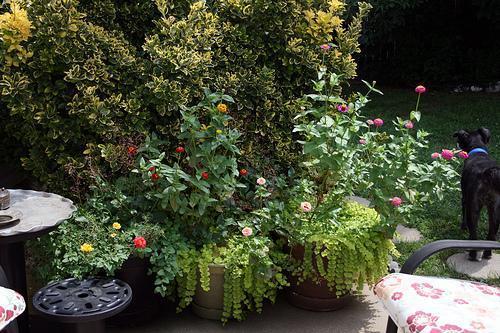How many dogs are pictured?
Give a very brief answer. 1. 